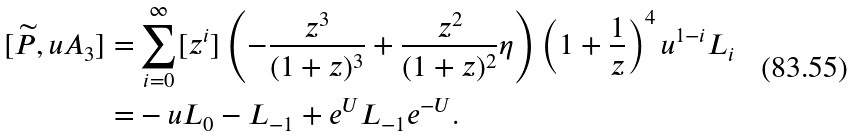<formula> <loc_0><loc_0><loc_500><loc_500>[ \widetilde { P } , u A _ { 3 } ] = & \sum _ { i = 0 } ^ { \infty } [ z ^ { i } ] \left ( - \frac { z ^ { 3 } } { ( 1 + z ) ^ { 3 } } + \frac { z ^ { 2 } } { ( 1 + z ) ^ { 2 } } \eta \right ) \left ( 1 + \frac { 1 } { z } \right ) ^ { 4 } u ^ { 1 - i } L _ { i } \\ = & - u L _ { 0 } - L _ { - 1 } + e ^ { U } L _ { - 1 } e ^ { - U } .</formula> 